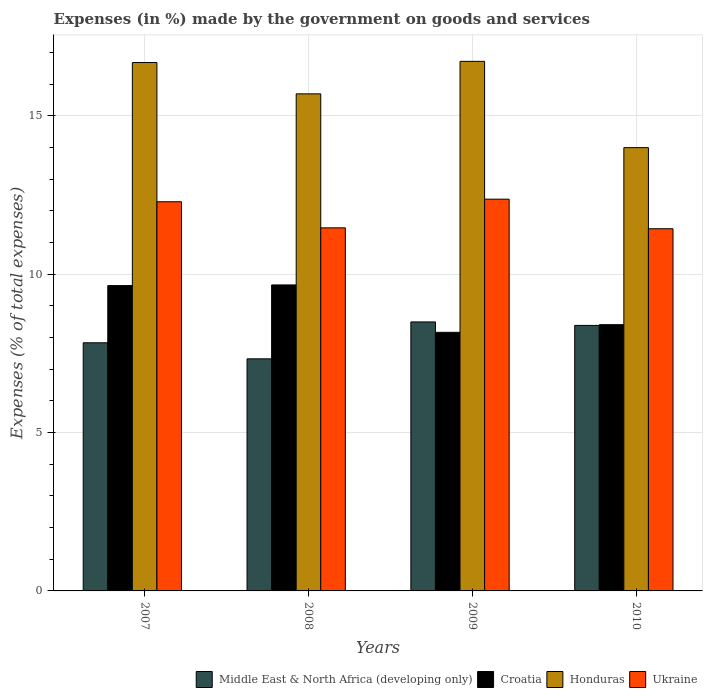How many groups of bars are there?
Your answer should be very brief. 4. Are the number of bars on each tick of the X-axis equal?
Give a very brief answer. Yes. How many bars are there on the 3rd tick from the right?
Keep it short and to the point. 4. What is the label of the 2nd group of bars from the left?
Ensure brevity in your answer.  2008. In how many cases, is the number of bars for a given year not equal to the number of legend labels?
Keep it short and to the point. 0. What is the percentage of expenses made by the government on goods and services in Ukraine in 2009?
Give a very brief answer. 12.37. Across all years, what is the maximum percentage of expenses made by the government on goods and services in Croatia?
Your answer should be very brief. 9.66. Across all years, what is the minimum percentage of expenses made by the government on goods and services in Honduras?
Offer a very short reply. 14. What is the total percentage of expenses made by the government on goods and services in Ukraine in the graph?
Ensure brevity in your answer.  47.56. What is the difference between the percentage of expenses made by the government on goods and services in Honduras in 2007 and that in 2008?
Offer a very short reply. 0.99. What is the difference between the percentage of expenses made by the government on goods and services in Middle East & North Africa (developing only) in 2007 and the percentage of expenses made by the government on goods and services in Croatia in 2009?
Your answer should be compact. -0.33. What is the average percentage of expenses made by the government on goods and services in Ukraine per year?
Offer a terse response. 11.89. In the year 2007, what is the difference between the percentage of expenses made by the government on goods and services in Middle East & North Africa (developing only) and percentage of expenses made by the government on goods and services in Croatia?
Offer a very short reply. -1.81. What is the ratio of the percentage of expenses made by the government on goods and services in Croatia in 2009 to that in 2010?
Your answer should be very brief. 0.97. Is the percentage of expenses made by the government on goods and services in Middle East & North Africa (developing only) in 2009 less than that in 2010?
Offer a very short reply. No. Is the difference between the percentage of expenses made by the government on goods and services in Middle East & North Africa (developing only) in 2007 and 2010 greater than the difference between the percentage of expenses made by the government on goods and services in Croatia in 2007 and 2010?
Offer a terse response. No. What is the difference between the highest and the second highest percentage of expenses made by the government on goods and services in Honduras?
Your answer should be very brief. 0.04. What is the difference between the highest and the lowest percentage of expenses made by the government on goods and services in Croatia?
Provide a short and direct response. 1.5. In how many years, is the percentage of expenses made by the government on goods and services in Middle East & North Africa (developing only) greater than the average percentage of expenses made by the government on goods and services in Middle East & North Africa (developing only) taken over all years?
Your answer should be compact. 2. What does the 2nd bar from the left in 2007 represents?
Your response must be concise. Croatia. What does the 2nd bar from the right in 2009 represents?
Your response must be concise. Honduras. Is it the case that in every year, the sum of the percentage of expenses made by the government on goods and services in Middle East & North Africa (developing only) and percentage of expenses made by the government on goods and services in Croatia is greater than the percentage of expenses made by the government on goods and services in Ukraine?
Ensure brevity in your answer.  Yes. Are all the bars in the graph horizontal?
Your response must be concise. No. What is the difference between two consecutive major ticks on the Y-axis?
Keep it short and to the point. 5. Are the values on the major ticks of Y-axis written in scientific E-notation?
Make the answer very short. No. Where does the legend appear in the graph?
Provide a short and direct response. Bottom right. What is the title of the graph?
Offer a very short reply. Expenses (in %) made by the government on goods and services. What is the label or title of the Y-axis?
Keep it short and to the point. Expenses (% of total expenses). What is the Expenses (% of total expenses) in Middle East & North Africa (developing only) in 2007?
Give a very brief answer. 7.84. What is the Expenses (% of total expenses) of Croatia in 2007?
Make the answer very short. 9.64. What is the Expenses (% of total expenses) of Honduras in 2007?
Your response must be concise. 16.69. What is the Expenses (% of total expenses) of Ukraine in 2007?
Provide a succinct answer. 12.29. What is the Expenses (% of total expenses) in Middle East & North Africa (developing only) in 2008?
Make the answer very short. 7.33. What is the Expenses (% of total expenses) of Croatia in 2008?
Make the answer very short. 9.66. What is the Expenses (% of total expenses) in Honduras in 2008?
Provide a succinct answer. 15.7. What is the Expenses (% of total expenses) in Ukraine in 2008?
Offer a terse response. 11.47. What is the Expenses (% of total expenses) in Middle East & North Africa (developing only) in 2009?
Offer a very short reply. 8.49. What is the Expenses (% of total expenses) in Croatia in 2009?
Your response must be concise. 8.17. What is the Expenses (% of total expenses) of Honduras in 2009?
Your answer should be compact. 16.72. What is the Expenses (% of total expenses) of Ukraine in 2009?
Give a very brief answer. 12.37. What is the Expenses (% of total expenses) of Middle East & North Africa (developing only) in 2010?
Ensure brevity in your answer.  8.38. What is the Expenses (% of total expenses) of Croatia in 2010?
Provide a succinct answer. 8.41. What is the Expenses (% of total expenses) in Honduras in 2010?
Offer a terse response. 14. What is the Expenses (% of total expenses) of Ukraine in 2010?
Your answer should be compact. 11.44. Across all years, what is the maximum Expenses (% of total expenses) in Middle East & North Africa (developing only)?
Your answer should be very brief. 8.49. Across all years, what is the maximum Expenses (% of total expenses) of Croatia?
Provide a succinct answer. 9.66. Across all years, what is the maximum Expenses (% of total expenses) of Honduras?
Your answer should be very brief. 16.72. Across all years, what is the maximum Expenses (% of total expenses) of Ukraine?
Ensure brevity in your answer.  12.37. Across all years, what is the minimum Expenses (% of total expenses) in Middle East & North Africa (developing only)?
Ensure brevity in your answer.  7.33. Across all years, what is the minimum Expenses (% of total expenses) in Croatia?
Offer a terse response. 8.17. Across all years, what is the minimum Expenses (% of total expenses) in Honduras?
Your answer should be compact. 14. Across all years, what is the minimum Expenses (% of total expenses) of Ukraine?
Provide a succinct answer. 11.44. What is the total Expenses (% of total expenses) of Middle East & North Africa (developing only) in the graph?
Provide a succinct answer. 32.04. What is the total Expenses (% of total expenses) of Croatia in the graph?
Provide a short and direct response. 35.88. What is the total Expenses (% of total expenses) of Honduras in the graph?
Offer a terse response. 63.1. What is the total Expenses (% of total expenses) of Ukraine in the graph?
Keep it short and to the point. 47.56. What is the difference between the Expenses (% of total expenses) in Middle East & North Africa (developing only) in 2007 and that in 2008?
Ensure brevity in your answer.  0.51. What is the difference between the Expenses (% of total expenses) of Croatia in 2007 and that in 2008?
Your answer should be compact. -0.02. What is the difference between the Expenses (% of total expenses) in Honduras in 2007 and that in 2008?
Keep it short and to the point. 0.99. What is the difference between the Expenses (% of total expenses) of Ukraine in 2007 and that in 2008?
Your response must be concise. 0.82. What is the difference between the Expenses (% of total expenses) of Middle East & North Africa (developing only) in 2007 and that in 2009?
Keep it short and to the point. -0.66. What is the difference between the Expenses (% of total expenses) in Croatia in 2007 and that in 2009?
Keep it short and to the point. 1.48. What is the difference between the Expenses (% of total expenses) of Honduras in 2007 and that in 2009?
Offer a terse response. -0.04. What is the difference between the Expenses (% of total expenses) of Ukraine in 2007 and that in 2009?
Give a very brief answer. -0.08. What is the difference between the Expenses (% of total expenses) in Middle East & North Africa (developing only) in 2007 and that in 2010?
Keep it short and to the point. -0.55. What is the difference between the Expenses (% of total expenses) in Croatia in 2007 and that in 2010?
Keep it short and to the point. 1.23. What is the difference between the Expenses (% of total expenses) in Honduras in 2007 and that in 2010?
Ensure brevity in your answer.  2.69. What is the difference between the Expenses (% of total expenses) in Ukraine in 2007 and that in 2010?
Give a very brief answer. 0.85. What is the difference between the Expenses (% of total expenses) in Middle East & North Africa (developing only) in 2008 and that in 2009?
Your response must be concise. -1.17. What is the difference between the Expenses (% of total expenses) in Croatia in 2008 and that in 2009?
Offer a terse response. 1.5. What is the difference between the Expenses (% of total expenses) of Honduras in 2008 and that in 2009?
Offer a terse response. -1.03. What is the difference between the Expenses (% of total expenses) in Ukraine in 2008 and that in 2009?
Provide a succinct answer. -0.91. What is the difference between the Expenses (% of total expenses) of Middle East & North Africa (developing only) in 2008 and that in 2010?
Your response must be concise. -1.06. What is the difference between the Expenses (% of total expenses) in Croatia in 2008 and that in 2010?
Your answer should be compact. 1.25. What is the difference between the Expenses (% of total expenses) in Honduras in 2008 and that in 2010?
Keep it short and to the point. 1.7. What is the difference between the Expenses (% of total expenses) of Ukraine in 2008 and that in 2010?
Offer a terse response. 0.03. What is the difference between the Expenses (% of total expenses) in Middle East & North Africa (developing only) in 2009 and that in 2010?
Provide a succinct answer. 0.11. What is the difference between the Expenses (% of total expenses) of Croatia in 2009 and that in 2010?
Provide a succinct answer. -0.24. What is the difference between the Expenses (% of total expenses) of Honduras in 2009 and that in 2010?
Your answer should be compact. 2.73. What is the difference between the Expenses (% of total expenses) in Ukraine in 2009 and that in 2010?
Ensure brevity in your answer.  0.93. What is the difference between the Expenses (% of total expenses) of Middle East & North Africa (developing only) in 2007 and the Expenses (% of total expenses) of Croatia in 2008?
Offer a very short reply. -1.83. What is the difference between the Expenses (% of total expenses) of Middle East & North Africa (developing only) in 2007 and the Expenses (% of total expenses) of Honduras in 2008?
Give a very brief answer. -7.86. What is the difference between the Expenses (% of total expenses) of Middle East & North Africa (developing only) in 2007 and the Expenses (% of total expenses) of Ukraine in 2008?
Give a very brief answer. -3.63. What is the difference between the Expenses (% of total expenses) in Croatia in 2007 and the Expenses (% of total expenses) in Honduras in 2008?
Your response must be concise. -6.05. What is the difference between the Expenses (% of total expenses) of Croatia in 2007 and the Expenses (% of total expenses) of Ukraine in 2008?
Ensure brevity in your answer.  -1.82. What is the difference between the Expenses (% of total expenses) in Honduras in 2007 and the Expenses (% of total expenses) in Ukraine in 2008?
Provide a short and direct response. 5.22. What is the difference between the Expenses (% of total expenses) of Middle East & North Africa (developing only) in 2007 and the Expenses (% of total expenses) of Croatia in 2009?
Offer a terse response. -0.33. What is the difference between the Expenses (% of total expenses) of Middle East & North Africa (developing only) in 2007 and the Expenses (% of total expenses) of Honduras in 2009?
Provide a short and direct response. -8.89. What is the difference between the Expenses (% of total expenses) of Middle East & North Africa (developing only) in 2007 and the Expenses (% of total expenses) of Ukraine in 2009?
Your response must be concise. -4.53. What is the difference between the Expenses (% of total expenses) in Croatia in 2007 and the Expenses (% of total expenses) in Honduras in 2009?
Provide a succinct answer. -7.08. What is the difference between the Expenses (% of total expenses) of Croatia in 2007 and the Expenses (% of total expenses) of Ukraine in 2009?
Keep it short and to the point. -2.73. What is the difference between the Expenses (% of total expenses) in Honduras in 2007 and the Expenses (% of total expenses) in Ukraine in 2009?
Your answer should be very brief. 4.32. What is the difference between the Expenses (% of total expenses) in Middle East & North Africa (developing only) in 2007 and the Expenses (% of total expenses) in Croatia in 2010?
Offer a very short reply. -0.57. What is the difference between the Expenses (% of total expenses) in Middle East & North Africa (developing only) in 2007 and the Expenses (% of total expenses) in Honduras in 2010?
Provide a short and direct response. -6.16. What is the difference between the Expenses (% of total expenses) of Middle East & North Africa (developing only) in 2007 and the Expenses (% of total expenses) of Ukraine in 2010?
Your answer should be compact. -3.6. What is the difference between the Expenses (% of total expenses) of Croatia in 2007 and the Expenses (% of total expenses) of Honduras in 2010?
Make the answer very short. -4.36. What is the difference between the Expenses (% of total expenses) in Croatia in 2007 and the Expenses (% of total expenses) in Ukraine in 2010?
Ensure brevity in your answer.  -1.79. What is the difference between the Expenses (% of total expenses) in Honduras in 2007 and the Expenses (% of total expenses) in Ukraine in 2010?
Your response must be concise. 5.25. What is the difference between the Expenses (% of total expenses) of Middle East & North Africa (developing only) in 2008 and the Expenses (% of total expenses) of Croatia in 2009?
Give a very brief answer. -0.84. What is the difference between the Expenses (% of total expenses) of Middle East & North Africa (developing only) in 2008 and the Expenses (% of total expenses) of Honduras in 2009?
Give a very brief answer. -9.39. What is the difference between the Expenses (% of total expenses) of Middle East & North Africa (developing only) in 2008 and the Expenses (% of total expenses) of Ukraine in 2009?
Your answer should be compact. -5.04. What is the difference between the Expenses (% of total expenses) in Croatia in 2008 and the Expenses (% of total expenses) in Honduras in 2009?
Your answer should be very brief. -7.06. What is the difference between the Expenses (% of total expenses) of Croatia in 2008 and the Expenses (% of total expenses) of Ukraine in 2009?
Your answer should be compact. -2.71. What is the difference between the Expenses (% of total expenses) in Honduras in 2008 and the Expenses (% of total expenses) in Ukraine in 2009?
Make the answer very short. 3.33. What is the difference between the Expenses (% of total expenses) in Middle East & North Africa (developing only) in 2008 and the Expenses (% of total expenses) in Croatia in 2010?
Offer a very short reply. -1.08. What is the difference between the Expenses (% of total expenses) of Middle East & North Africa (developing only) in 2008 and the Expenses (% of total expenses) of Honduras in 2010?
Offer a terse response. -6.67. What is the difference between the Expenses (% of total expenses) in Middle East & North Africa (developing only) in 2008 and the Expenses (% of total expenses) in Ukraine in 2010?
Offer a terse response. -4.11. What is the difference between the Expenses (% of total expenses) in Croatia in 2008 and the Expenses (% of total expenses) in Honduras in 2010?
Offer a terse response. -4.33. What is the difference between the Expenses (% of total expenses) in Croatia in 2008 and the Expenses (% of total expenses) in Ukraine in 2010?
Make the answer very short. -1.77. What is the difference between the Expenses (% of total expenses) in Honduras in 2008 and the Expenses (% of total expenses) in Ukraine in 2010?
Keep it short and to the point. 4.26. What is the difference between the Expenses (% of total expenses) of Middle East & North Africa (developing only) in 2009 and the Expenses (% of total expenses) of Croatia in 2010?
Ensure brevity in your answer.  0.09. What is the difference between the Expenses (% of total expenses) in Middle East & North Africa (developing only) in 2009 and the Expenses (% of total expenses) in Honduras in 2010?
Offer a very short reply. -5.5. What is the difference between the Expenses (% of total expenses) of Middle East & North Africa (developing only) in 2009 and the Expenses (% of total expenses) of Ukraine in 2010?
Your answer should be very brief. -2.94. What is the difference between the Expenses (% of total expenses) in Croatia in 2009 and the Expenses (% of total expenses) in Honduras in 2010?
Make the answer very short. -5.83. What is the difference between the Expenses (% of total expenses) of Croatia in 2009 and the Expenses (% of total expenses) of Ukraine in 2010?
Your answer should be compact. -3.27. What is the difference between the Expenses (% of total expenses) of Honduras in 2009 and the Expenses (% of total expenses) of Ukraine in 2010?
Ensure brevity in your answer.  5.29. What is the average Expenses (% of total expenses) in Middle East & North Africa (developing only) per year?
Offer a very short reply. 8.01. What is the average Expenses (% of total expenses) of Croatia per year?
Provide a short and direct response. 8.97. What is the average Expenses (% of total expenses) in Honduras per year?
Give a very brief answer. 15.78. What is the average Expenses (% of total expenses) of Ukraine per year?
Offer a terse response. 11.89. In the year 2007, what is the difference between the Expenses (% of total expenses) in Middle East & North Africa (developing only) and Expenses (% of total expenses) in Croatia?
Offer a terse response. -1.81. In the year 2007, what is the difference between the Expenses (% of total expenses) of Middle East & North Africa (developing only) and Expenses (% of total expenses) of Honduras?
Provide a short and direct response. -8.85. In the year 2007, what is the difference between the Expenses (% of total expenses) of Middle East & North Africa (developing only) and Expenses (% of total expenses) of Ukraine?
Ensure brevity in your answer.  -4.45. In the year 2007, what is the difference between the Expenses (% of total expenses) in Croatia and Expenses (% of total expenses) in Honduras?
Make the answer very short. -7.04. In the year 2007, what is the difference between the Expenses (% of total expenses) in Croatia and Expenses (% of total expenses) in Ukraine?
Provide a succinct answer. -2.65. In the year 2007, what is the difference between the Expenses (% of total expenses) in Honduras and Expenses (% of total expenses) in Ukraine?
Ensure brevity in your answer.  4.4. In the year 2008, what is the difference between the Expenses (% of total expenses) in Middle East & North Africa (developing only) and Expenses (% of total expenses) in Croatia?
Give a very brief answer. -2.33. In the year 2008, what is the difference between the Expenses (% of total expenses) of Middle East & North Africa (developing only) and Expenses (% of total expenses) of Honduras?
Provide a succinct answer. -8.37. In the year 2008, what is the difference between the Expenses (% of total expenses) in Middle East & North Africa (developing only) and Expenses (% of total expenses) in Ukraine?
Offer a very short reply. -4.14. In the year 2008, what is the difference between the Expenses (% of total expenses) in Croatia and Expenses (% of total expenses) in Honduras?
Your response must be concise. -6.03. In the year 2008, what is the difference between the Expenses (% of total expenses) of Croatia and Expenses (% of total expenses) of Ukraine?
Provide a short and direct response. -1.8. In the year 2008, what is the difference between the Expenses (% of total expenses) of Honduras and Expenses (% of total expenses) of Ukraine?
Offer a terse response. 4.23. In the year 2009, what is the difference between the Expenses (% of total expenses) of Middle East & North Africa (developing only) and Expenses (% of total expenses) of Croatia?
Offer a terse response. 0.33. In the year 2009, what is the difference between the Expenses (% of total expenses) in Middle East & North Africa (developing only) and Expenses (% of total expenses) in Honduras?
Ensure brevity in your answer.  -8.23. In the year 2009, what is the difference between the Expenses (% of total expenses) in Middle East & North Africa (developing only) and Expenses (% of total expenses) in Ukraine?
Ensure brevity in your answer.  -3.88. In the year 2009, what is the difference between the Expenses (% of total expenses) of Croatia and Expenses (% of total expenses) of Honduras?
Keep it short and to the point. -8.56. In the year 2009, what is the difference between the Expenses (% of total expenses) in Croatia and Expenses (% of total expenses) in Ukraine?
Your answer should be compact. -4.2. In the year 2009, what is the difference between the Expenses (% of total expenses) of Honduras and Expenses (% of total expenses) of Ukraine?
Provide a succinct answer. 4.35. In the year 2010, what is the difference between the Expenses (% of total expenses) of Middle East & North Africa (developing only) and Expenses (% of total expenses) of Croatia?
Ensure brevity in your answer.  -0.02. In the year 2010, what is the difference between the Expenses (% of total expenses) of Middle East & North Africa (developing only) and Expenses (% of total expenses) of Honduras?
Your response must be concise. -5.61. In the year 2010, what is the difference between the Expenses (% of total expenses) of Middle East & North Africa (developing only) and Expenses (% of total expenses) of Ukraine?
Provide a succinct answer. -3.05. In the year 2010, what is the difference between the Expenses (% of total expenses) in Croatia and Expenses (% of total expenses) in Honduras?
Ensure brevity in your answer.  -5.59. In the year 2010, what is the difference between the Expenses (% of total expenses) of Croatia and Expenses (% of total expenses) of Ukraine?
Provide a short and direct response. -3.03. In the year 2010, what is the difference between the Expenses (% of total expenses) of Honduras and Expenses (% of total expenses) of Ukraine?
Your answer should be compact. 2.56. What is the ratio of the Expenses (% of total expenses) of Middle East & North Africa (developing only) in 2007 to that in 2008?
Provide a succinct answer. 1.07. What is the ratio of the Expenses (% of total expenses) of Croatia in 2007 to that in 2008?
Offer a terse response. 1. What is the ratio of the Expenses (% of total expenses) of Honduras in 2007 to that in 2008?
Provide a short and direct response. 1.06. What is the ratio of the Expenses (% of total expenses) of Ukraine in 2007 to that in 2008?
Your answer should be very brief. 1.07. What is the ratio of the Expenses (% of total expenses) in Middle East & North Africa (developing only) in 2007 to that in 2009?
Offer a terse response. 0.92. What is the ratio of the Expenses (% of total expenses) of Croatia in 2007 to that in 2009?
Your answer should be very brief. 1.18. What is the ratio of the Expenses (% of total expenses) of Middle East & North Africa (developing only) in 2007 to that in 2010?
Provide a short and direct response. 0.93. What is the ratio of the Expenses (% of total expenses) of Croatia in 2007 to that in 2010?
Your answer should be compact. 1.15. What is the ratio of the Expenses (% of total expenses) of Honduras in 2007 to that in 2010?
Provide a succinct answer. 1.19. What is the ratio of the Expenses (% of total expenses) in Ukraine in 2007 to that in 2010?
Offer a terse response. 1.07. What is the ratio of the Expenses (% of total expenses) in Middle East & North Africa (developing only) in 2008 to that in 2009?
Offer a very short reply. 0.86. What is the ratio of the Expenses (% of total expenses) of Croatia in 2008 to that in 2009?
Provide a succinct answer. 1.18. What is the ratio of the Expenses (% of total expenses) in Honduras in 2008 to that in 2009?
Keep it short and to the point. 0.94. What is the ratio of the Expenses (% of total expenses) in Ukraine in 2008 to that in 2009?
Offer a terse response. 0.93. What is the ratio of the Expenses (% of total expenses) in Middle East & North Africa (developing only) in 2008 to that in 2010?
Ensure brevity in your answer.  0.87. What is the ratio of the Expenses (% of total expenses) in Croatia in 2008 to that in 2010?
Provide a succinct answer. 1.15. What is the ratio of the Expenses (% of total expenses) in Honduras in 2008 to that in 2010?
Your response must be concise. 1.12. What is the ratio of the Expenses (% of total expenses) of Middle East & North Africa (developing only) in 2009 to that in 2010?
Give a very brief answer. 1.01. What is the ratio of the Expenses (% of total expenses) in Croatia in 2009 to that in 2010?
Provide a succinct answer. 0.97. What is the ratio of the Expenses (% of total expenses) in Honduras in 2009 to that in 2010?
Provide a succinct answer. 1.19. What is the ratio of the Expenses (% of total expenses) in Ukraine in 2009 to that in 2010?
Your answer should be compact. 1.08. What is the difference between the highest and the second highest Expenses (% of total expenses) of Middle East & North Africa (developing only)?
Your answer should be compact. 0.11. What is the difference between the highest and the second highest Expenses (% of total expenses) of Croatia?
Offer a very short reply. 0.02. What is the difference between the highest and the second highest Expenses (% of total expenses) of Honduras?
Offer a terse response. 0.04. What is the difference between the highest and the second highest Expenses (% of total expenses) in Ukraine?
Your answer should be compact. 0.08. What is the difference between the highest and the lowest Expenses (% of total expenses) of Middle East & North Africa (developing only)?
Give a very brief answer. 1.17. What is the difference between the highest and the lowest Expenses (% of total expenses) in Croatia?
Offer a very short reply. 1.5. What is the difference between the highest and the lowest Expenses (% of total expenses) of Honduras?
Provide a short and direct response. 2.73. What is the difference between the highest and the lowest Expenses (% of total expenses) of Ukraine?
Ensure brevity in your answer.  0.93. 